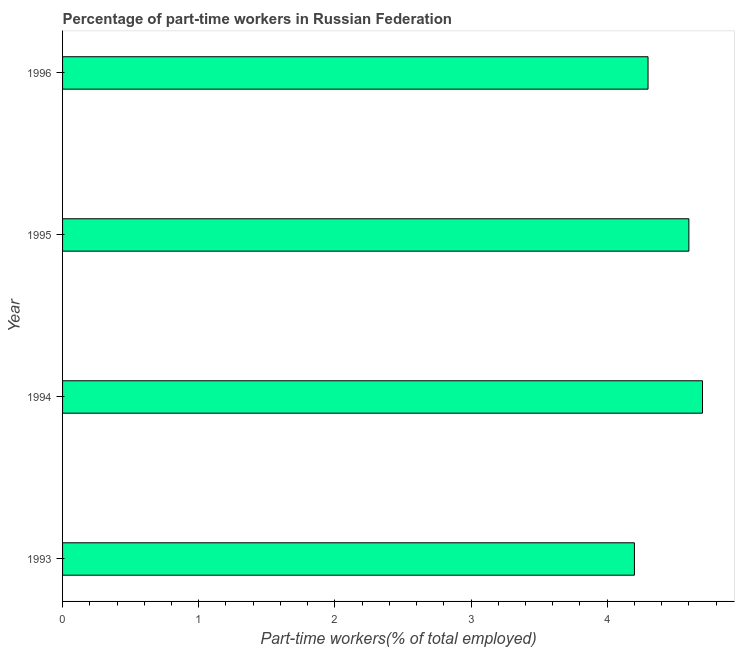Does the graph contain grids?
Give a very brief answer. No. What is the title of the graph?
Offer a terse response. Percentage of part-time workers in Russian Federation. What is the label or title of the X-axis?
Your answer should be very brief. Part-time workers(% of total employed). What is the label or title of the Y-axis?
Keep it short and to the point. Year. What is the percentage of part-time workers in 1993?
Your answer should be compact. 4.2. Across all years, what is the maximum percentage of part-time workers?
Make the answer very short. 4.7. Across all years, what is the minimum percentage of part-time workers?
Offer a very short reply. 4.2. In which year was the percentage of part-time workers maximum?
Make the answer very short. 1994. What is the sum of the percentage of part-time workers?
Make the answer very short. 17.8. What is the average percentage of part-time workers per year?
Make the answer very short. 4.45. What is the median percentage of part-time workers?
Make the answer very short. 4.45. In how many years, is the percentage of part-time workers greater than 1.8 %?
Your response must be concise. 4. What is the ratio of the percentage of part-time workers in 1993 to that in 1995?
Your answer should be compact. 0.91. Is the percentage of part-time workers in 1993 less than that in 1995?
Your answer should be compact. Yes. Is the sum of the percentage of part-time workers in 1994 and 1996 greater than the maximum percentage of part-time workers across all years?
Provide a succinct answer. Yes. What is the difference between the highest and the lowest percentage of part-time workers?
Your answer should be very brief. 0.5. How many years are there in the graph?
Provide a succinct answer. 4. What is the Part-time workers(% of total employed) of 1993?
Keep it short and to the point. 4.2. What is the Part-time workers(% of total employed) in 1994?
Provide a succinct answer. 4.7. What is the Part-time workers(% of total employed) in 1995?
Give a very brief answer. 4.6. What is the Part-time workers(% of total employed) in 1996?
Give a very brief answer. 4.3. What is the difference between the Part-time workers(% of total employed) in 1993 and 1994?
Provide a succinct answer. -0.5. What is the difference between the Part-time workers(% of total employed) in 1993 and 1996?
Give a very brief answer. -0.1. What is the ratio of the Part-time workers(% of total employed) in 1993 to that in 1994?
Make the answer very short. 0.89. What is the ratio of the Part-time workers(% of total employed) in 1993 to that in 1995?
Offer a terse response. 0.91. What is the ratio of the Part-time workers(% of total employed) in 1994 to that in 1996?
Provide a short and direct response. 1.09. What is the ratio of the Part-time workers(% of total employed) in 1995 to that in 1996?
Your response must be concise. 1.07. 